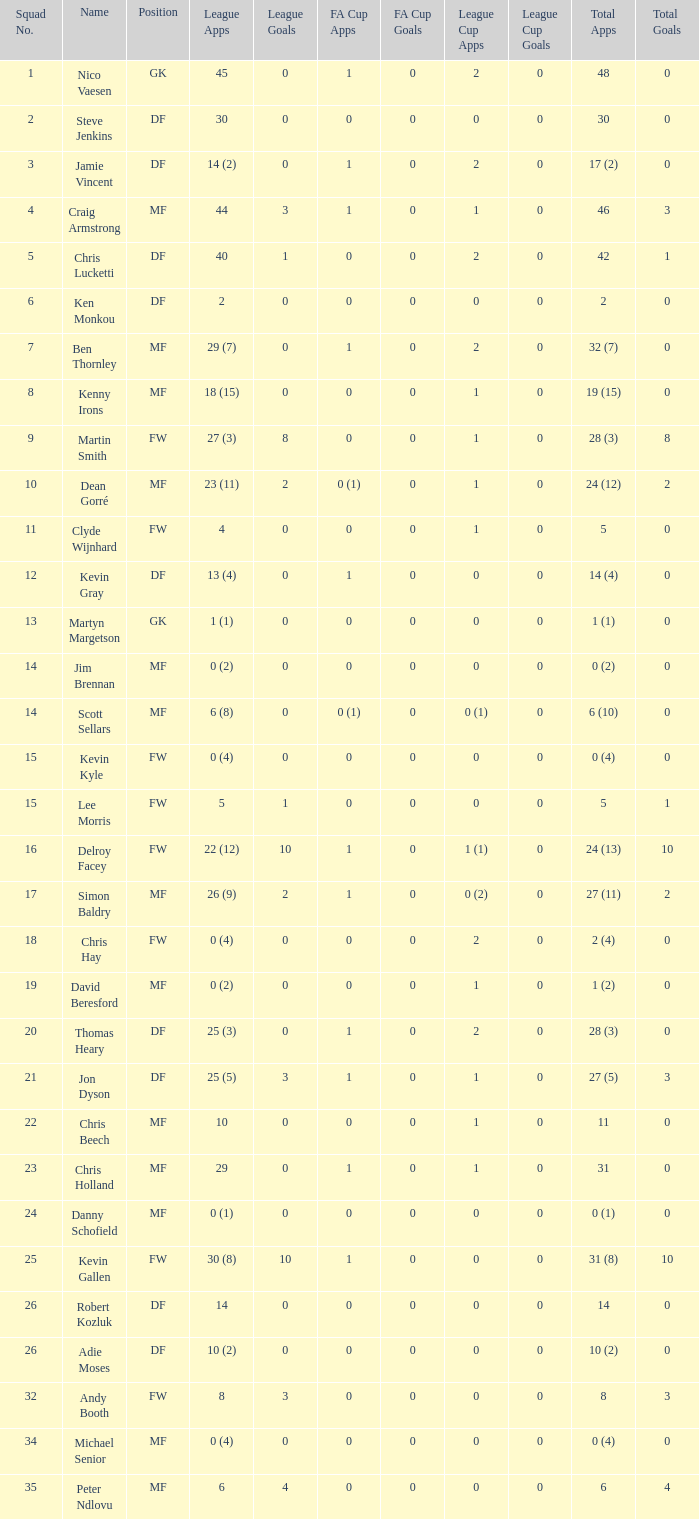Can you tell me the sum of FA Cup Goals that has the League Cup Goals larger than 0? None. Could you parse the entire table as a dict? {'header': ['Squad No.', 'Name', 'Position', 'League Apps', 'League Goals', 'FA Cup Apps', 'FA Cup Goals', 'League Cup Apps', 'League Cup Goals', 'Total Apps', 'Total Goals'], 'rows': [['1', 'Nico Vaesen', 'GK', '45', '0', '1', '0', '2', '0', '48', '0'], ['2', 'Steve Jenkins', 'DF', '30', '0', '0', '0', '0', '0', '30', '0'], ['3', 'Jamie Vincent', 'DF', '14 (2)', '0', '1', '0', '2', '0', '17 (2)', '0'], ['4', 'Craig Armstrong', 'MF', '44', '3', '1', '0', '1', '0', '46', '3'], ['5', 'Chris Lucketti', 'DF', '40', '1', '0', '0', '2', '0', '42', '1'], ['6', 'Ken Monkou', 'DF', '2', '0', '0', '0', '0', '0', '2', '0'], ['7', 'Ben Thornley', 'MF', '29 (7)', '0', '1', '0', '2', '0', '32 (7)', '0'], ['8', 'Kenny Irons', 'MF', '18 (15)', '0', '0', '0', '1', '0', '19 (15)', '0'], ['9', 'Martin Smith', 'FW', '27 (3)', '8', '0', '0', '1', '0', '28 (3)', '8'], ['10', 'Dean Gorré', 'MF', '23 (11)', '2', '0 (1)', '0', '1', '0', '24 (12)', '2'], ['11', 'Clyde Wijnhard', 'FW', '4', '0', '0', '0', '1', '0', '5', '0'], ['12', 'Kevin Gray', 'DF', '13 (4)', '0', '1', '0', '0', '0', '14 (4)', '0'], ['13', 'Martyn Margetson', 'GK', '1 (1)', '0', '0', '0', '0', '0', '1 (1)', '0'], ['14', 'Jim Brennan', 'MF', '0 (2)', '0', '0', '0', '0', '0', '0 (2)', '0'], ['14', 'Scott Sellars', 'MF', '6 (8)', '0', '0 (1)', '0', '0 (1)', '0', '6 (10)', '0'], ['15', 'Kevin Kyle', 'FW', '0 (4)', '0', '0', '0', '0', '0', '0 (4)', '0'], ['15', 'Lee Morris', 'FW', '5', '1', '0', '0', '0', '0', '5', '1'], ['16', 'Delroy Facey', 'FW', '22 (12)', '10', '1', '0', '1 (1)', '0', '24 (13)', '10'], ['17', 'Simon Baldry', 'MF', '26 (9)', '2', '1', '0', '0 (2)', '0', '27 (11)', '2'], ['18', 'Chris Hay', 'FW', '0 (4)', '0', '0', '0', '2', '0', '2 (4)', '0'], ['19', 'David Beresford', 'MF', '0 (2)', '0', '0', '0', '1', '0', '1 (2)', '0'], ['20', 'Thomas Heary', 'DF', '25 (3)', '0', '1', '0', '2', '0', '28 (3)', '0'], ['21', 'Jon Dyson', 'DF', '25 (5)', '3', '1', '0', '1', '0', '27 (5)', '3'], ['22', 'Chris Beech', 'MF', '10', '0', '0', '0', '1', '0', '11', '0'], ['23', 'Chris Holland', 'MF', '29', '0', '1', '0', '1', '0', '31', '0'], ['24', 'Danny Schofield', 'MF', '0 (1)', '0', '0', '0', '0', '0', '0 (1)', '0'], ['25', 'Kevin Gallen', 'FW', '30 (8)', '10', '1', '0', '0', '0', '31 (8)', '10'], ['26', 'Robert Kozluk', 'DF', '14', '0', '0', '0', '0', '0', '14', '0'], ['26', 'Adie Moses', 'DF', '10 (2)', '0', '0', '0', '0', '0', '10 (2)', '0'], ['32', 'Andy Booth', 'FW', '8', '3', '0', '0', '0', '0', '8', '3'], ['34', 'Michael Senior', 'MF', '0 (4)', '0', '0', '0', '0', '0', '0 (4)', '0'], ['35', 'Peter Ndlovu', 'MF', '6', '4', '0', '0', '0', '0', '6', '4']]} 